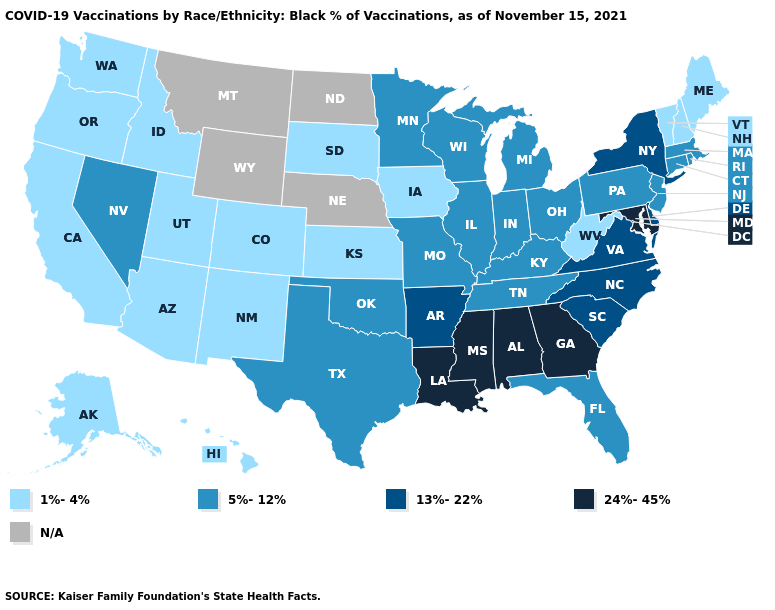What is the value of Washington?
Answer briefly. 1%-4%. What is the lowest value in the USA?
Concise answer only. 1%-4%. What is the highest value in the USA?
Short answer required. 24%-45%. Does Hawaii have the lowest value in the USA?
Keep it brief. Yes. Does Louisiana have the highest value in the USA?
Short answer required. Yes. Does Wisconsin have the highest value in the USA?
Keep it brief. No. What is the value of Iowa?
Be succinct. 1%-4%. What is the value of Louisiana?
Short answer required. 24%-45%. Among the states that border Alabama , which have the highest value?
Concise answer only. Georgia, Mississippi. Among the states that border Kentucky , which have the lowest value?
Be succinct. West Virginia. What is the value of Vermont?
Be succinct. 1%-4%. What is the value of Missouri?
Keep it brief. 5%-12%. Does Kentucky have the lowest value in the South?
Give a very brief answer. No. Does the first symbol in the legend represent the smallest category?
Quick response, please. Yes. 